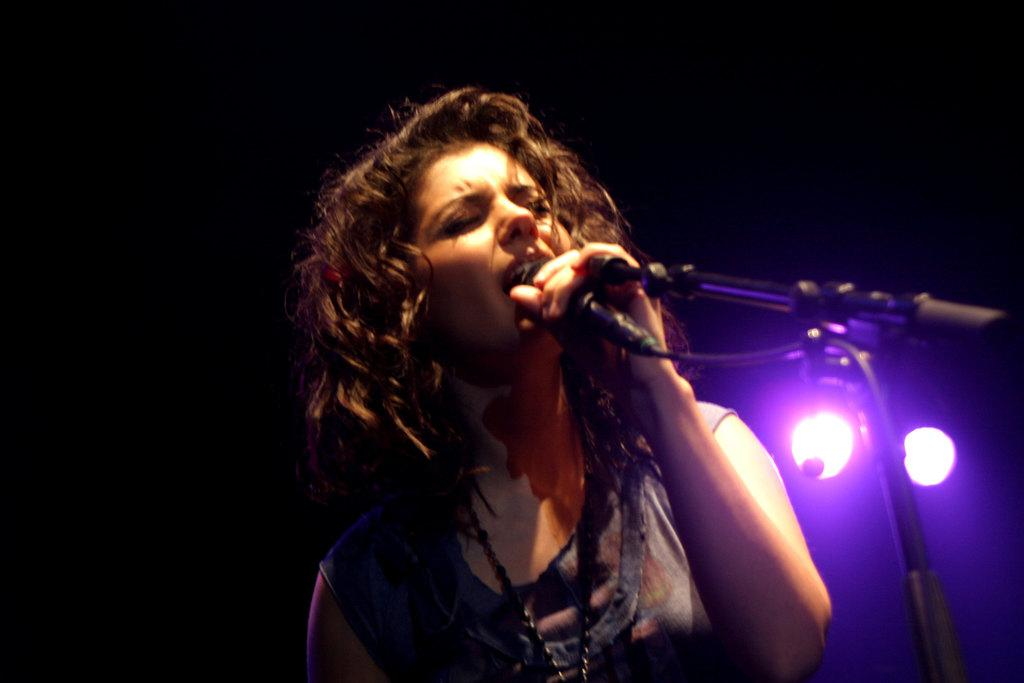What is the main subject of the image? There is a person in the image. What is the person doing in the image? The person is standing in front of a mic and singing. What can be seen in the background of the image? There are lights in the background of the image. What type of list is the person holding in the image? There is no list present in the image; the person is singing in front of a mic. What color is the underwear the person is wearing in the image? The image does not show the person's underwear, so it cannot be determined from the image. 